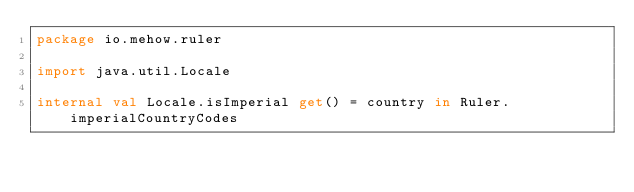<code> <loc_0><loc_0><loc_500><loc_500><_Kotlin_>package io.mehow.ruler

import java.util.Locale

internal val Locale.isImperial get() = country in Ruler.imperialCountryCodes
</code> 